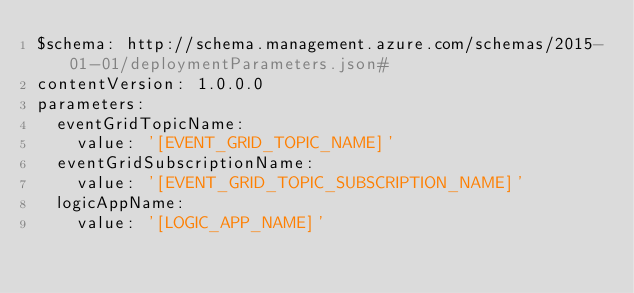<code> <loc_0><loc_0><loc_500><loc_500><_YAML_>$schema: http://schema.management.azure.com/schemas/2015-01-01/deploymentParameters.json#
contentVersion: 1.0.0.0
parameters:
  eventGridTopicName:
    value: '[EVENT_GRID_TOPIC_NAME]'
  eventGridSubscriptionName:
    value: '[EVENT_GRID_TOPIC_SUBSCRIPTION_NAME]'
  logicAppName:
    value: '[LOGIC_APP_NAME]'
</code> 